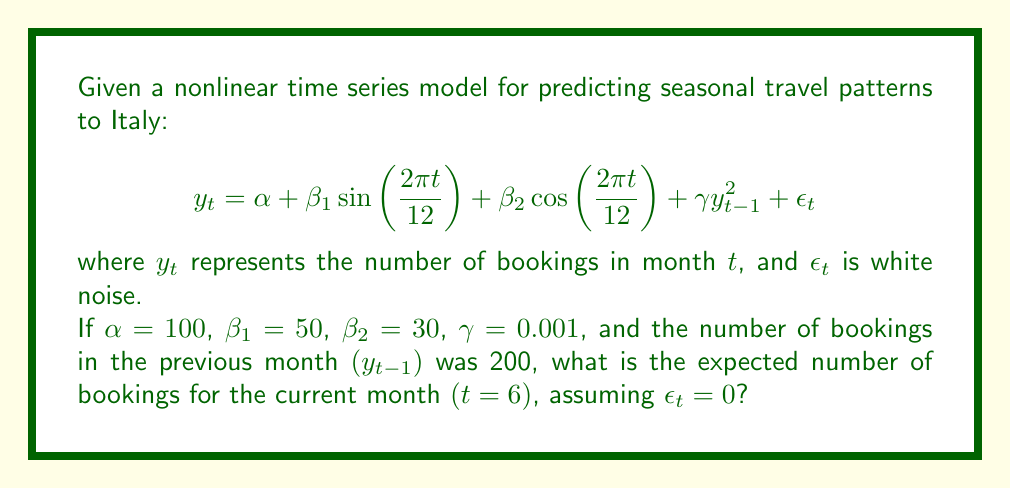What is the answer to this math problem? To solve this problem, we'll follow these steps:

1) First, let's recall the given model:
   $$y_t = \alpha + \beta_1 \sin\left(\frac{2\pi t}{12}\right) + \beta_2 \cos\left(\frac{2\pi t}{12}\right) + \gamma y_{t-1}^2 + \epsilon_t$$

2) We're given the following values:
   $\alpha = 100$, $\beta_1 = 50$, $\beta_2 = 30$, $\gamma = 0.001$, $y_{t-1} = 200$, $t = 6$, and $\epsilon_t = 0$

3) Let's substitute these values into the equation:
   $$y_6 = 100 + 50 \sin\left(\frac{2\pi \cdot 6}{12}\right) + 30 \cos\left(\frac{2\pi \cdot 6}{12}\right) + 0.001 \cdot 200^2 + 0$$

4) Simplify the trigonometric terms:
   $\frac{2\pi \cdot 6}{12} = \pi$
   $\sin(\pi) = 0$
   $\cos(\pi) = -1$

5) Substitute these values:
   $$y_6 = 100 + 50 \cdot 0 + 30 \cdot (-1) + 0.001 \cdot 200^2 + 0$$

6) Simplify:
   $$y_6 = 100 - 30 + 0.001 \cdot 40000$$
   $$y_6 = 70 + 40$$
   $$y_6 = 110$$

Therefore, the expected number of bookings for the current month (t = 6) is 110.
Answer: 110 bookings 